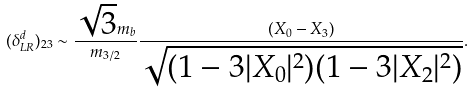Convert formula to latex. <formula><loc_0><loc_0><loc_500><loc_500>( \delta ^ { d } _ { L R } ) _ { 2 3 } \sim \frac { \sqrt { 3 } m _ { b } } { m _ { 3 / 2 } } \frac { ( X _ { 0 } - X _ { 3 } ) } { \sqrt { ( 1 - 3 | X _ { 0 } | ^ { 2 } ) ( 1 - 3 | X _ { 2 } | ^ { 2 } ) } } .</formula> 